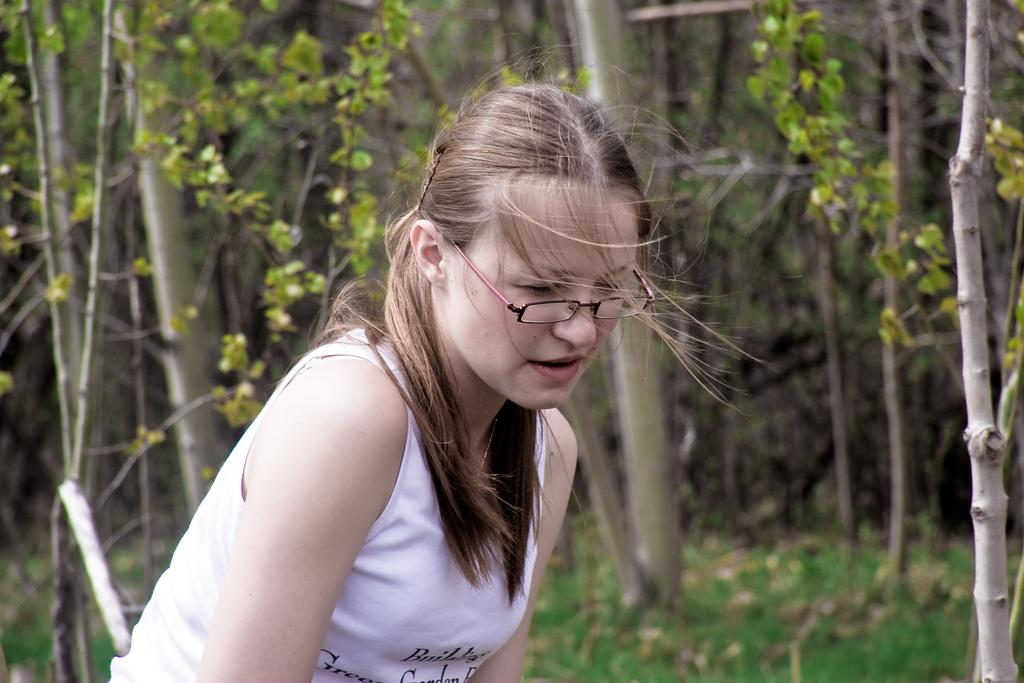Who is present in the image? There is a woman in the image. What accessory is the woman wearing? The woman is wearing spectacles. What can be seen in the background of the image? There are trees in the background of the image. How many sheep can be seen in the image? There are no sheep present in the image. What type of mark is visible on the woman's face in the image? There is no mark visible on the woman's face in the image. 